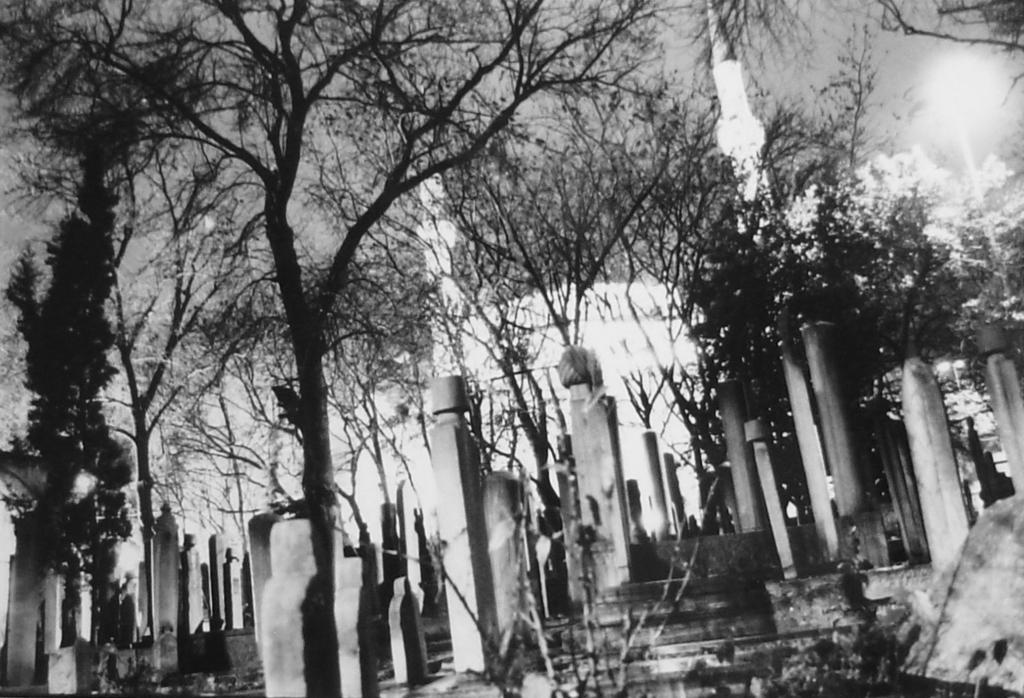Please provide a concise description of this image. In the image, it seems to be cemetery on the left side with steps on the right side with pillars on either side of it, in the front there are trees all over the image followed by a building it and above its sky, this is a black and white picture. 